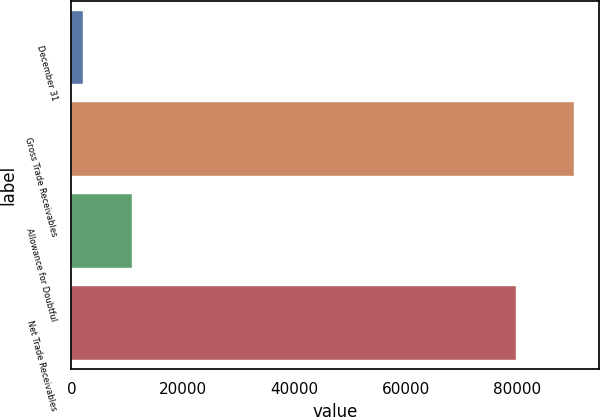Convert chart to OTSL. <chart><loc_0><loc_0><loc_500><loc_500><bar_chart><fcel>December 31<fcel>Gross Trade Receivables<fcel>Allowance for Doubtful<fcel>Net Trade Receivables<nl><fcel>2015<fcel>90212<fcel>10834.7<fcel>79864<nl></chart> 